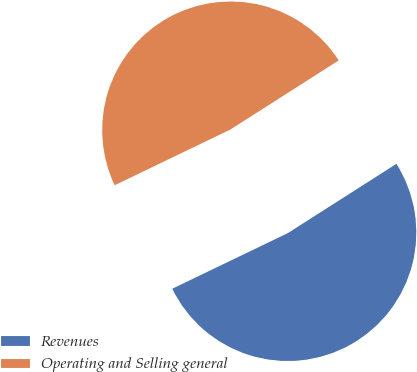Convert chart. <chart><loc_0><loc_0><loc_500><loc_500><pie_chart><fcel>Revenues<fcel>Operating and Selling general<nl><fcel>51.9%<fcel>48.1%<nl></chart> 